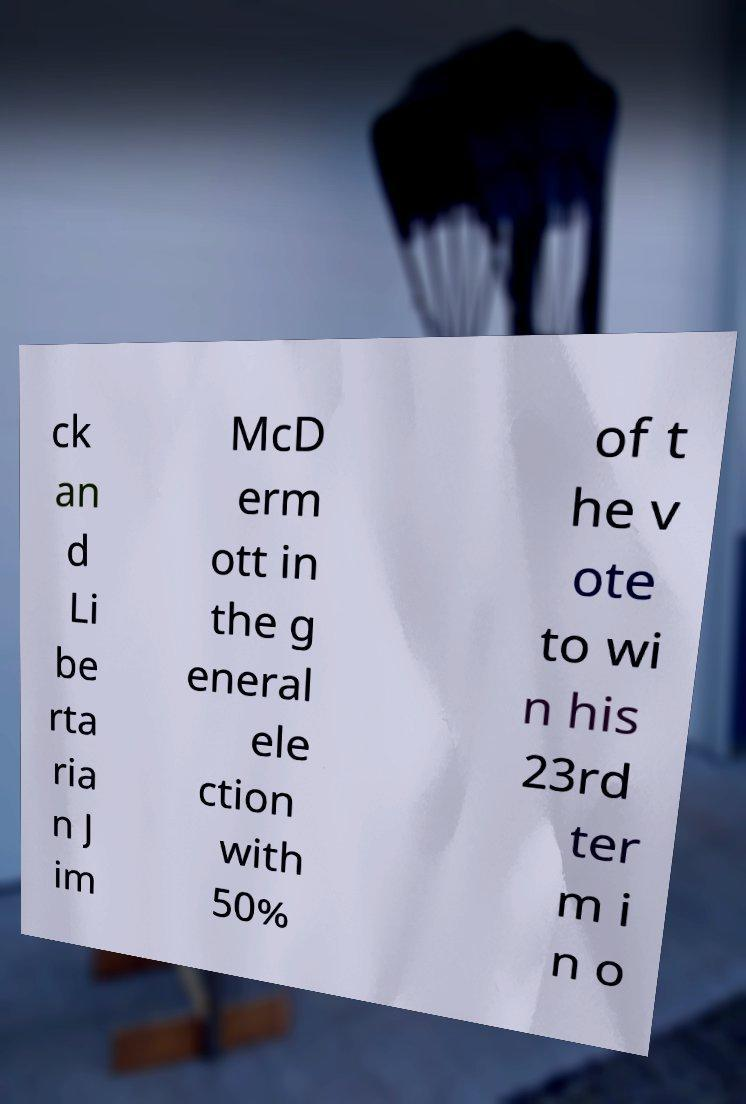What messages or text are displayed in this image? I need them in a readable, typed format. ck an d Li be rta ria n J im McD erm ott in the g eneral ele ction with 50% of t he v ote to wi n his 23rd ter m i n o 